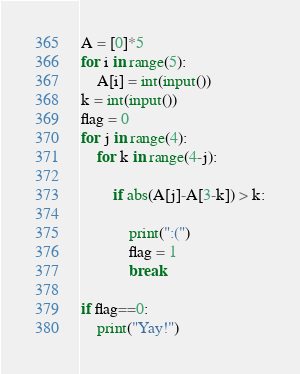Convert code to text. <code><loc_0><loc_0><loc_500><loc_500><_Python_>A = [0]*5
for i in range(5):
    A[i] = int(input())
k = int(input())
flag = 0
for j in range(4):
    for k in range(4-j):

        if abs(A[j]-A[3-k]) > k:

            print(":(")
            flag = 1
            break

if flag==0:
    print("Yay!")</code> 